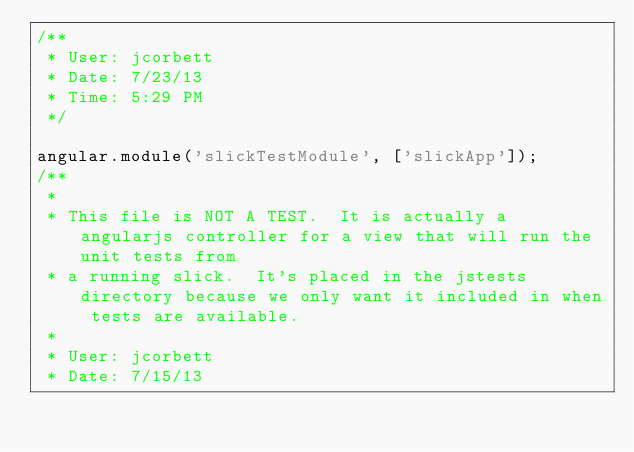<code> <loc_0><loc_0><loc_500><loc_500><_JavaScript_>/**
 * User: jcorbett
 * Date: 7/23/13
 * Time: 5:29 PM
 */

angular.module('slickTestModule', ['slickApp']);
/**
 *
 * This file is NOT A TEST.  It is actually a angularjs controller for a view that will run the unit tests from
 * a running slick.  It's placed in the jstests directory because we only want it included in when tests are available.
 *
 * User: jcorbett
 * Date: 7/15/13</code> 